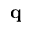<formula> <loc_0><loc_0><loc_500><loc_500>q</formula> 